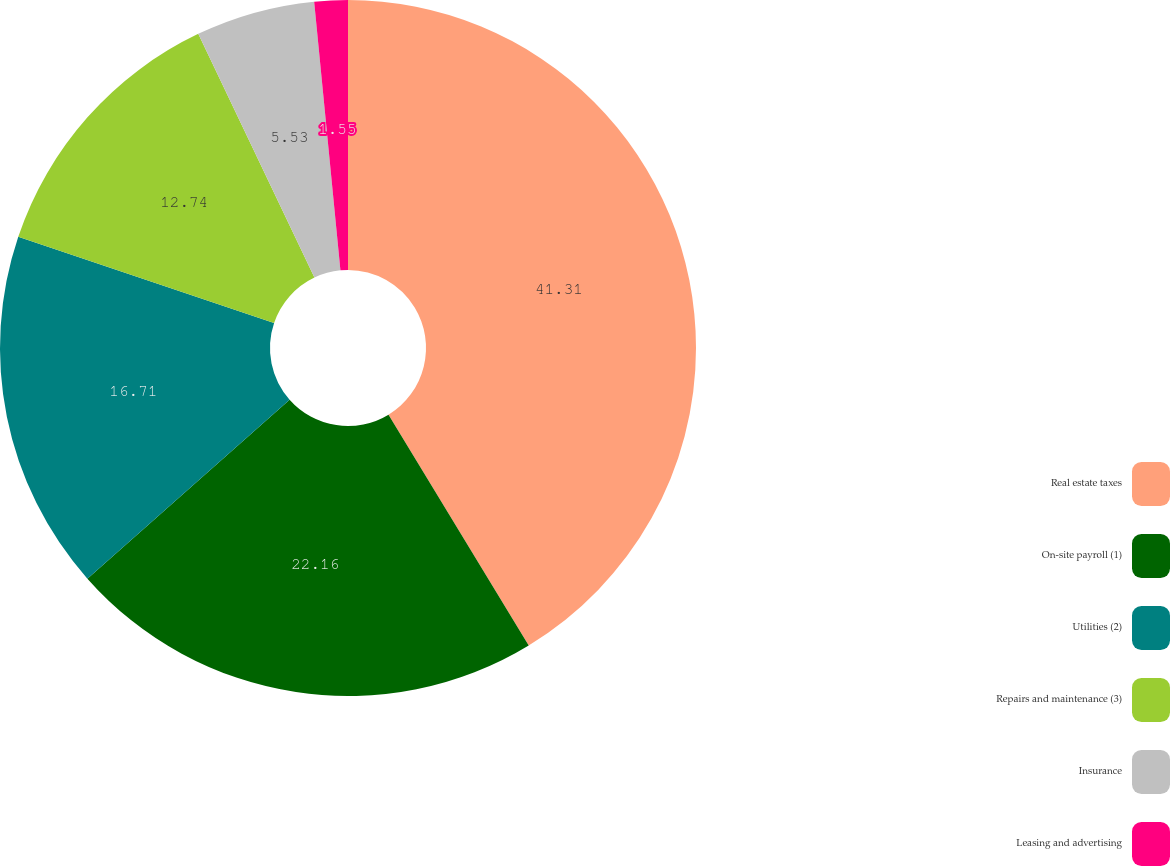Convert chart to OTSL. <chart><loc_0><loc_0><loc_500><loc_500><pie_chart><fcel>Real estate taxes<fcel>On-site payroll (1)<fcel>Utilities (2)<fcel>Repairs and maintenance (3)<fcel>Insurance<fcel>Leasing and advertising<nl><fcel>41.31%<fcel>22.16%<fcel>16.71%<fcel>12.74%<fcel>5.53%<fcel>1.55%<nl></chart> 